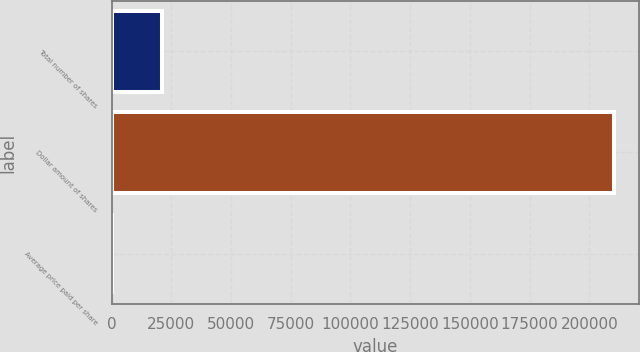<chart> <loc_0><loc_0><loc_500><loc_500><bar_chart><fcel>Total number of shares<fcel>Dollar amount of shares<fcel>Average price paid per share<nl><fcel>21098.5<fcel>210259<fcel>80.67<nl></chart> 